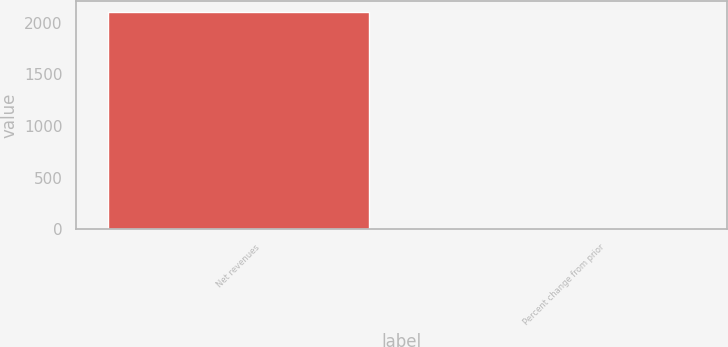<chart> <loc_0><loc_0><loc_500><loc_500><bar_chart><fcel>Net revenues<fcel>Percent change from prior<nl><fcel>2099<fcel>1<nl></chart> 